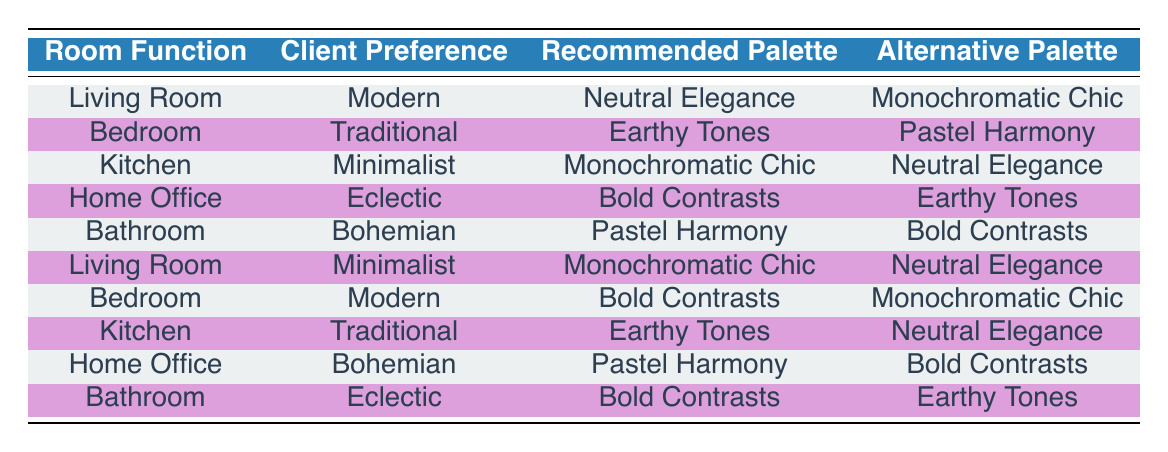What is the recommended color palette for a modern living room? The table indicates that for a living room with a modern client preference, the recommended color palette is "Neutral Elegance."
Answer: Neutral Elegance Which color palette is an alternative for a minimalist kitchen? According to the table, for a kitchen with a minimalist client preference, the alternative palette is "Neutral Elegance."
Answer: Neutral Elegance Are there any recommended palettes for a bedroom with a modern client preference? Yes, the table shows that for a modern bedroom, the recommended palette is "Bold Contrasts."
Answer: Yes What is the relationship between client preference and the type of palette recommended for a home office? For a home office with an eclectic client preference, the recommended palette is "Bold Contrasts," while an alternative palette is "Earthy Tones." This indicates that the eclectic style leans towards bolder color choices.
Answer: Bold Contrasts What are the two alternative palettes recommended for a bedroom with a traditional client preference? The table reveals that for a traditional bedroom, the recommended palette is "Earthy Tones" and the alternative is "Pastel Harmony." Hence, these two palettes are linked to the traditional style.
Answer: Earthy Tones and Pastel Harmony How many unique recommended palettes are identified in the decision matrix? There are five unique recommended palettes listed: "Neutral Elegance," "Bold Contrasts," "Earthy Tones," "Pastel Harmony," and "Monochromatic Chic." This is counted by observing each unique entry in the recommended palettes column.
Answer: 5 For a bathroom with an eclectic preference, what is the recommended and alternative palette? The table specifies that for a bathroom with an eclectic preference, the recommended palette is "Bold Contrasts" and the alternative is "Earthy Tones." This shows how eclectic preferences tend toward vibrant color combinations.
Answer: Bold Contrasts and Earthy Tones Is it true that the recommended palette for a kitchen with a traditional client preference is the same as for a bedroom with a traditional client preference? Yes, both rooms have "Earthy Tones" as the recommended palette, indicating that traditional preferences favor this palette across different rooms.
Answer: Yes What is the alternative color palette for a living room with a minimalist client preference? In the table, for a minimalist living room, the alternative color palette is "Neutral Elegance," providing another option besides the recommended palette.
Answer: Neutral Elegance 